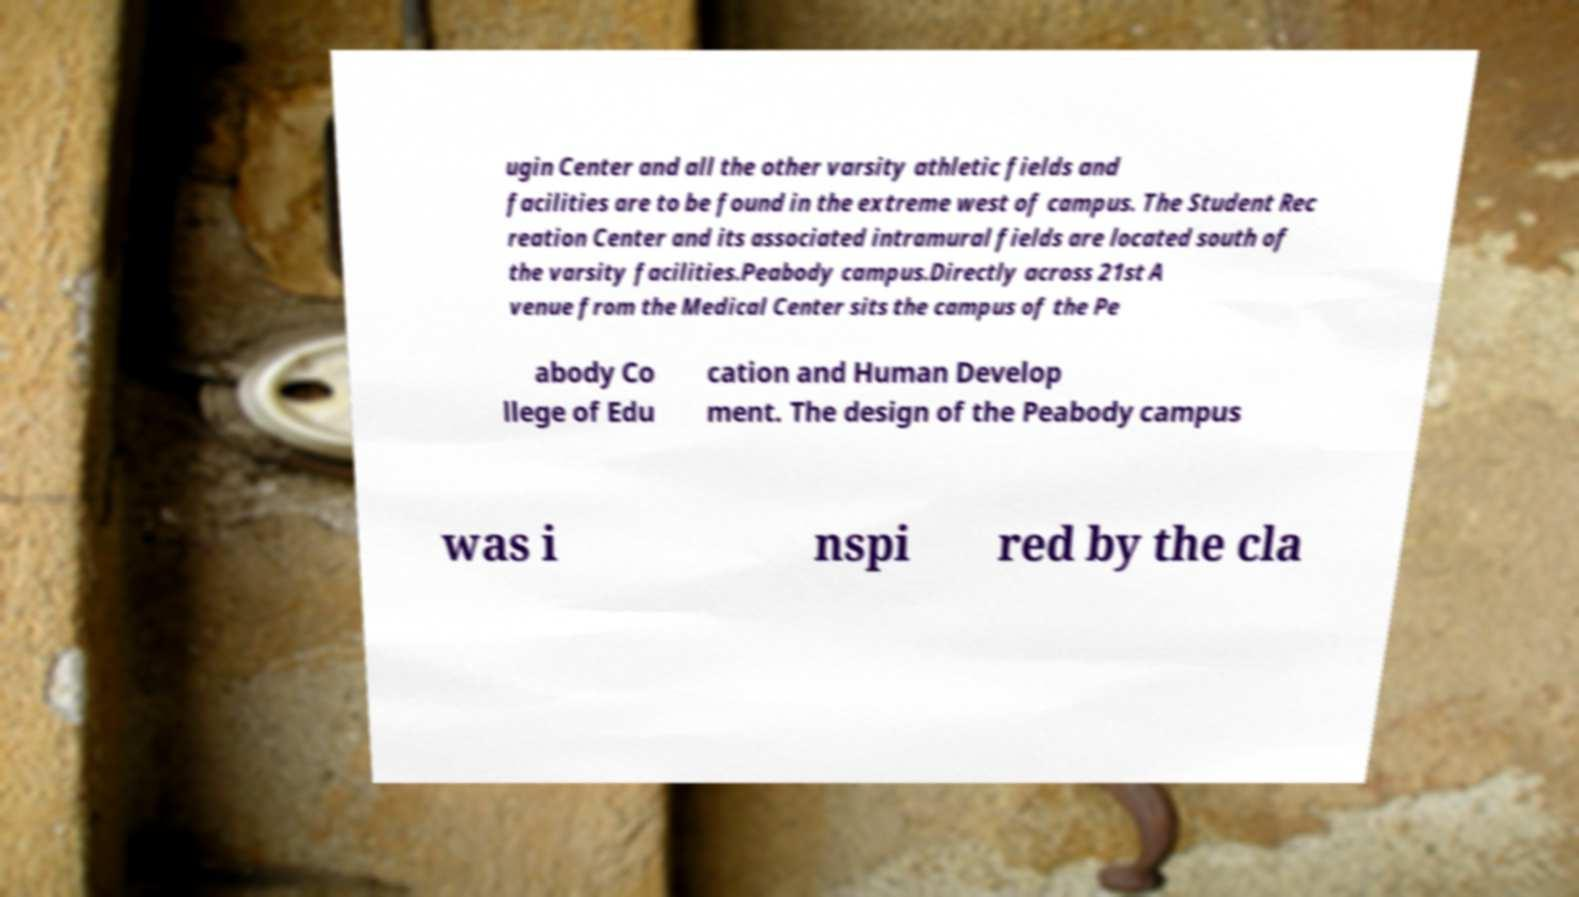For documentation purposes, I need the text within this image transcribed. Could you provide that? ugin Center and all the other varsity athletic fields and facilities are to be found in the extreme west of campus. The Student Rec reation Center and its associated intramural fields are located south of the varsity facilities.Peabody campus.Directly across 21st A venue from the Medical Center sits the campus of the Pe abody Co llege of Edu cation and Human Develop ment. The design of the Peabody campus was i nspi red by the cla 